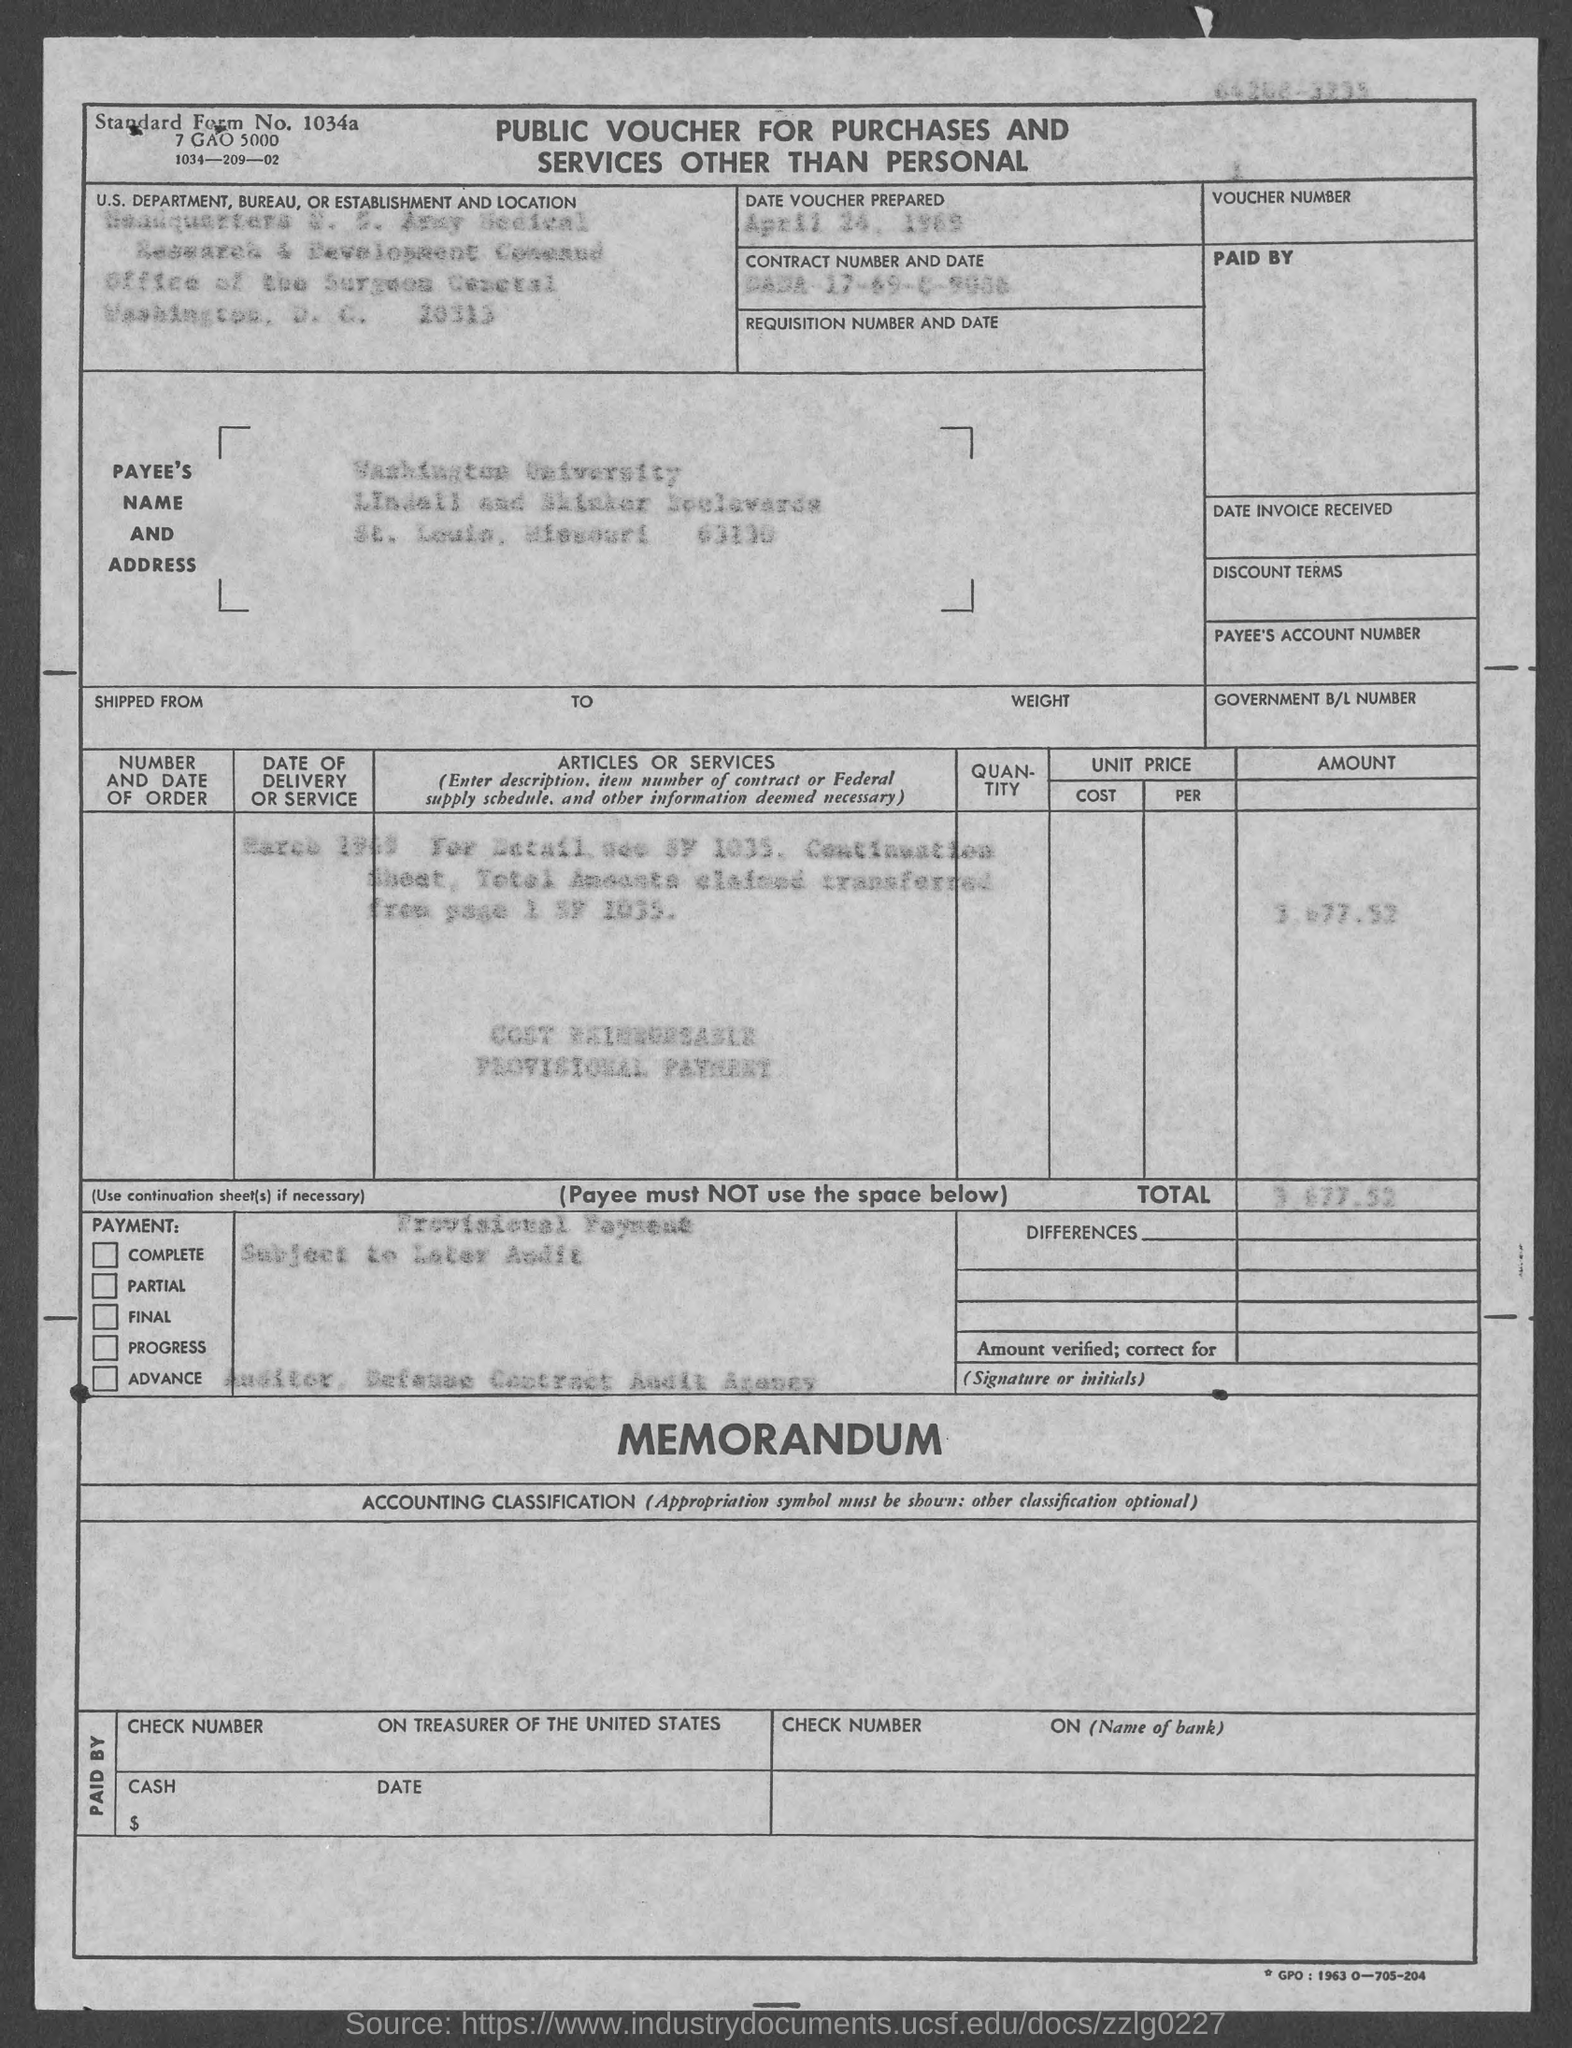Point out several critical features in this image. The voucher was prepared on April 24, 1969. 